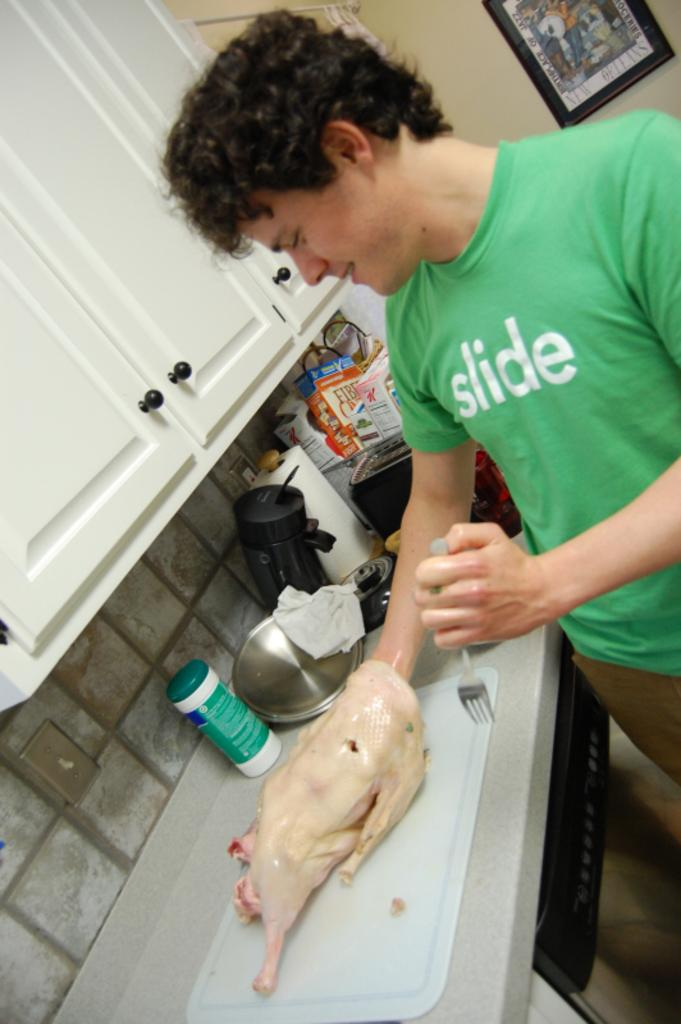<image>
Give a short and clear explanation of the subsequent image. A man with a green shirt that reads "slide" is standing in a kitchen with his hand inside a plucked chicken on the counter. 